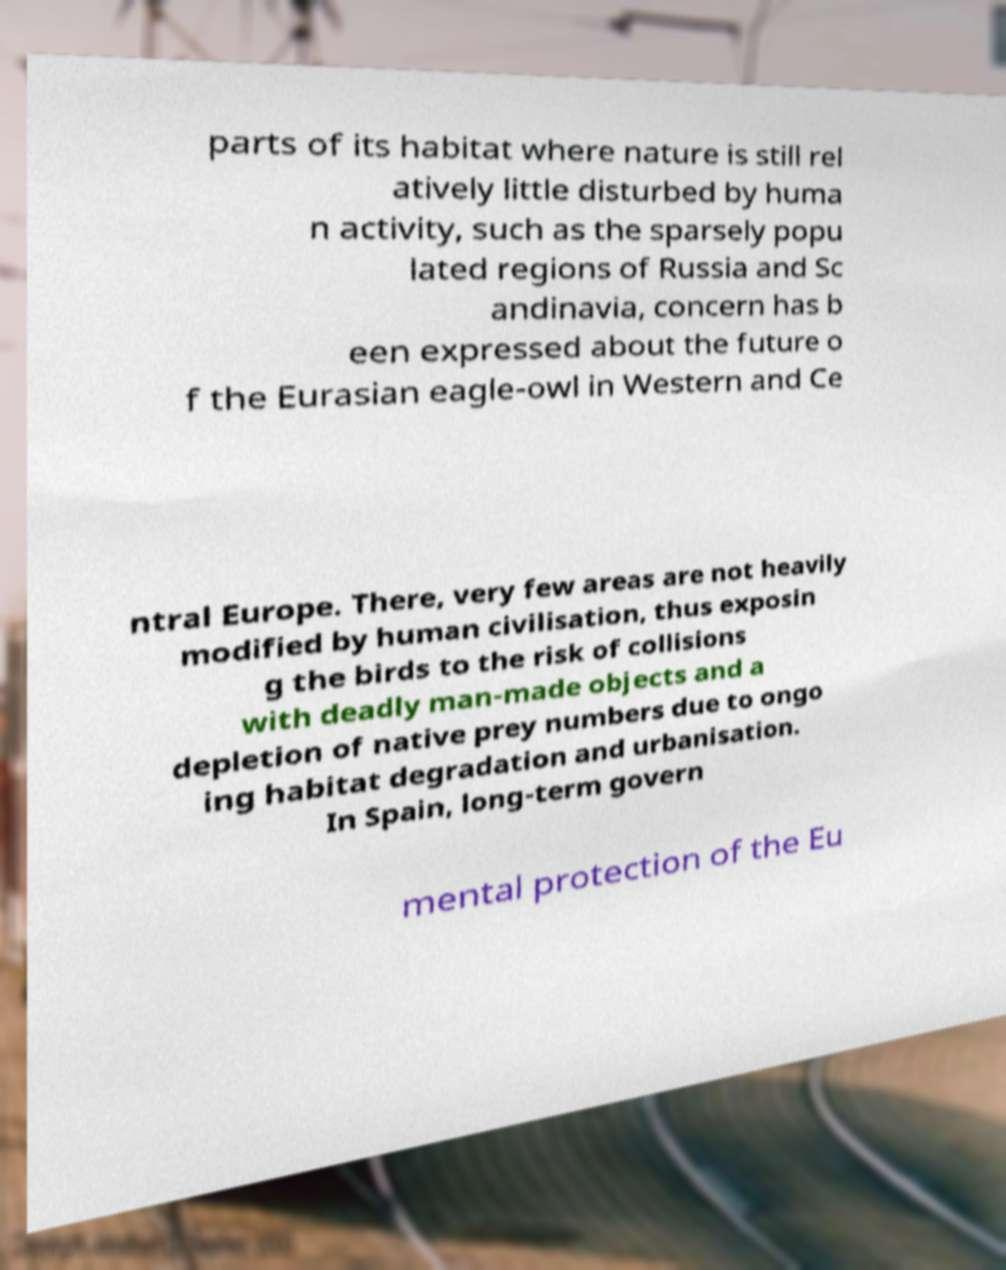Can you accurately transcribe the text from the provided image for me? parts of its habitat where nature is still rel atively little disturbed by huma n activity, such as the sparsely popu lated regions of Russia and Sc andinavia, concern has b een expressed about the future o f the Eurasian eagle-owl in Western and Ce ntral Europe. There, very few areas are not heavily modified by human civilisation, thus exposin g the birds to the risk of collisions with deadly man-made objects and a depletion of native prey numbers due to ongo ing habitat degradation and urbanisation. In Spain, long-term govern mental protection of the Eu 